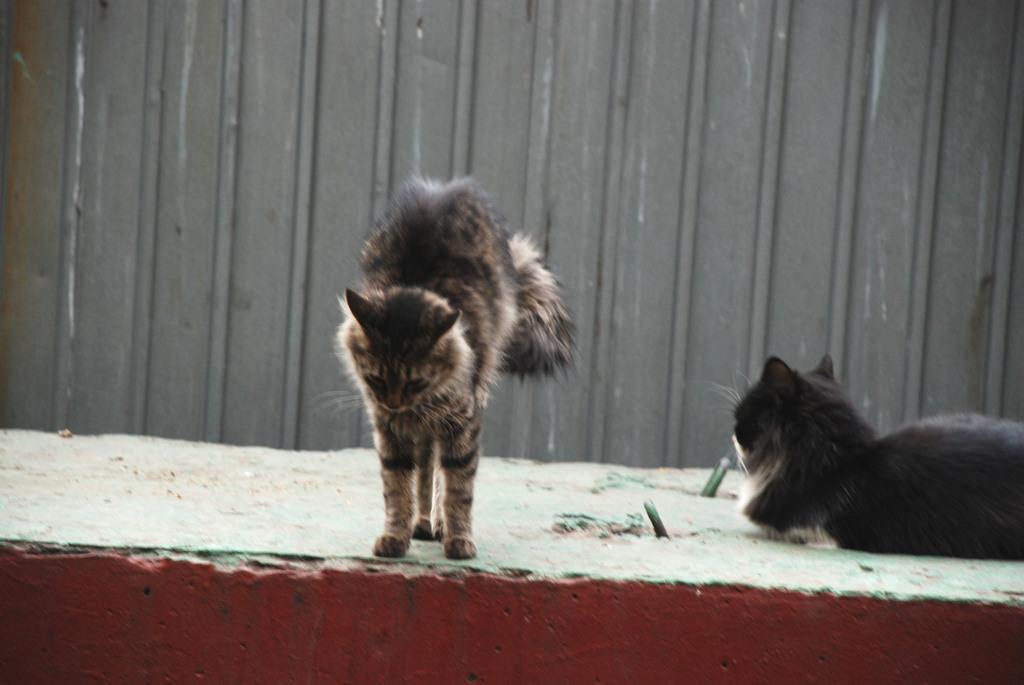What is the main subject in the foreground of the image? There is a cat in the foreground of the image. Are there any other cats visible in the image? Yes, there is another cat on the right side of the image. What can be seen in the background of the image? There appears to be a metal sheet in the background of the image. What type of work is the cat doing in the image? The cat is not depicted as doing any work in the image; it is simply sitting or standing. 